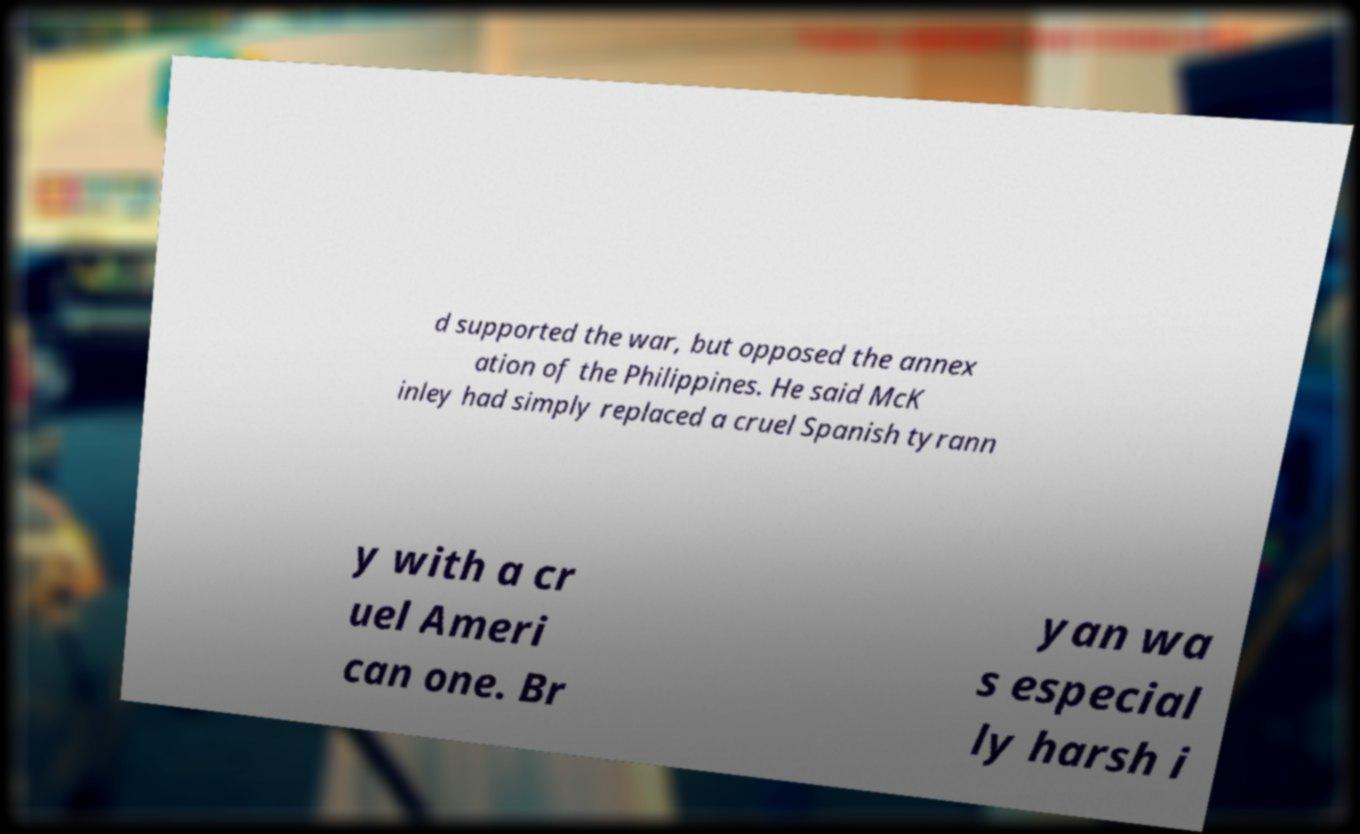Can you accurately transcribe the text from the provided image for me? d supported the war, but opposed the annex ation of the Philippines. He said McK inley had simply replaced a cruel Spanish tyrann y with a cr uel Ameri can one. Br yan wa s especial ly harsh i 